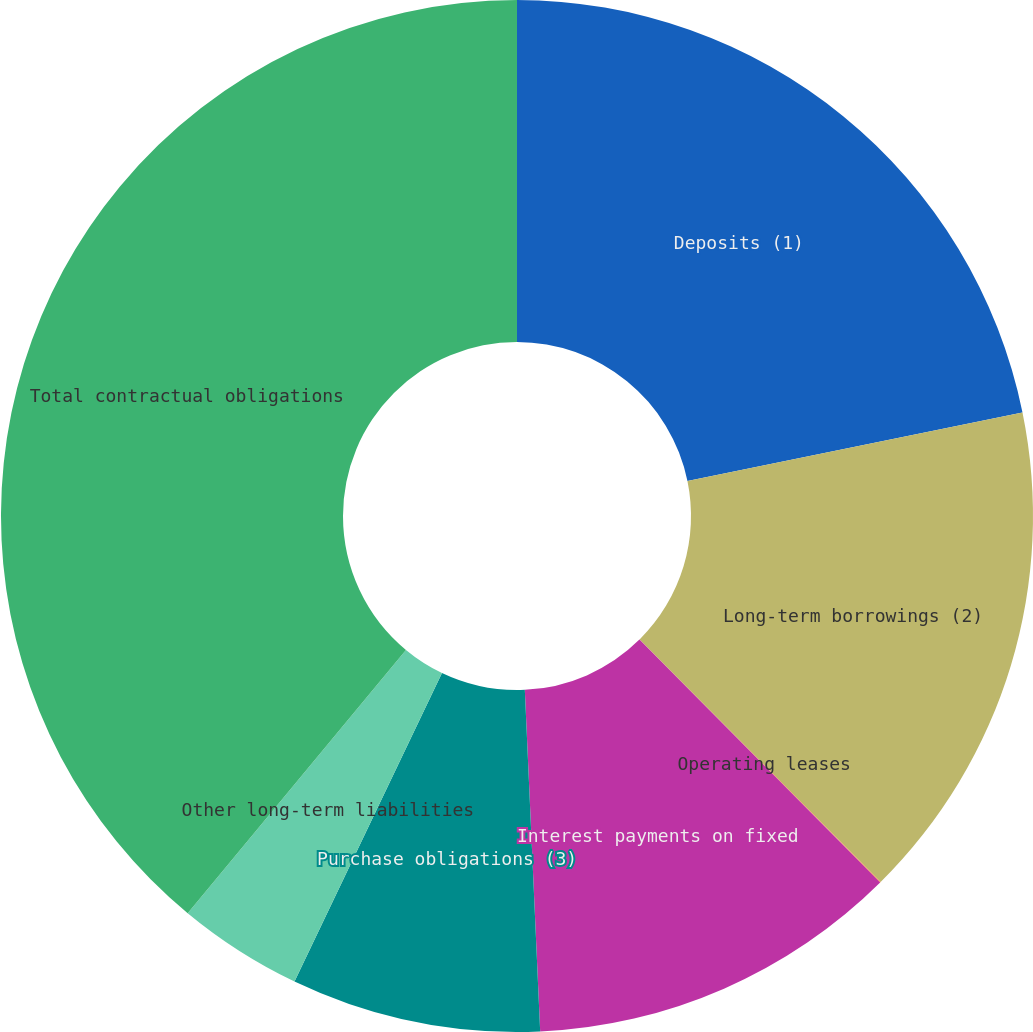Convert chart. <chart><loc_0><loc_0><loc_500><loc_500><pie_chart><fcel>Deposits (1)<fcel>Long-term borrowings (2)<fcel>Operating leases<fcel>Interest payments on fixed<fcel>Purchase obligations (3)<fcel>Other long-term liabilities<fcel>Total contractual obligations<nl><fcel>21.78%<fcel>15.77%<fcel>0.02%<fcel>11.71%<fcel>7.81%<fcel>3.92%<fcel>38.98%<nl></chart> 